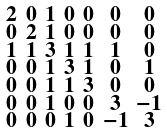Convert formula to latex. <formula><loc_0><loc_0><loc_500><loc_500>\begin{smallmatrix} 2 & 0 & 1 & 0 & 0 & 0 & 0 \\ 0 & 2 & 1 & 0 & 0 & 0 & 0 \\ 1 & 1 & 3 & 1 & 1 & 1 & 0 \\ 0 & 0 & 1 & 3 & 1 & 0 & 1 \\ 0 & 0 & 1 & 1 & 3 & 0 & 0 \\ 0 & 0 & 1 & 0 & 0 & 3 & - 1 \\ 0 & 0 & 0 & 1 & 0 & - 1 & 3 \end{smallmatrix}</formula> 